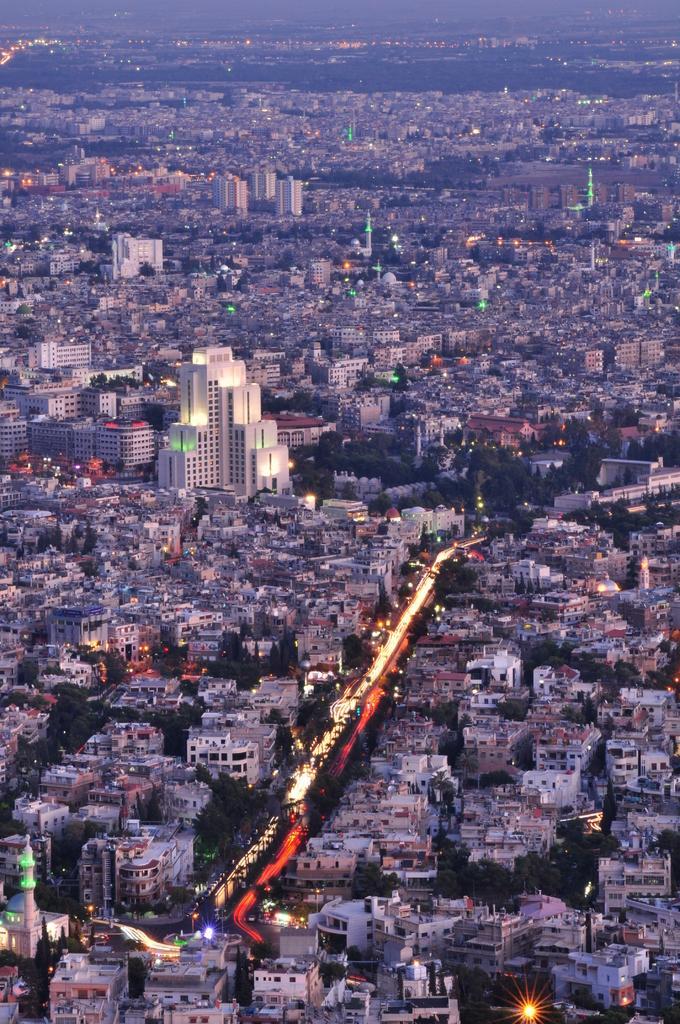Can you describe this image briefly? In this image we can see a group of buildings, towers, lights, trees and the pathway. 